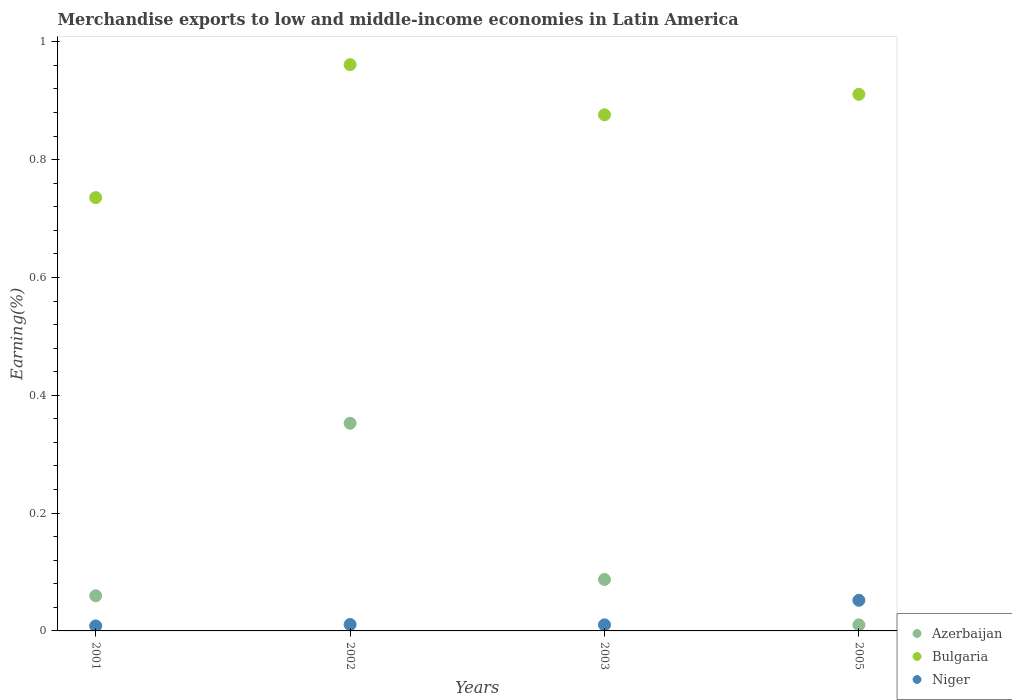What is the percentage of amount earned from merchandise exports in Bulgaria in 2002?
Give a very brief answer. 0.96. Across all years, what is the maximum percentage of amount earned from merchandise exports in Bulgaria?
Ensure brevity in your answer.  0.96. Across all years, what is the minimum percentage of amount earned from merchandise exports in Azerbaijan?
Your response must be concise. 0.01. In which year was the percentage of amount earned from merchandise exports in Niger maximum?
Provide a succinct answer. 2005. What is the total percentage of amount earned from merchandise exports in Azerbaijan in the graph?
Offer a terse response. 0.51. What is the difference between the percentage of amount earned from merchandise exports in Niger in 2001 and that in 2005?
Keep it short and to the point. -0.04. What is the difference between the percentage of amount earned from merchandise exports in Niger in 2003 and the percentage of amount earned from merchandise exports in Azerbaijan in 2005?
Offer a terse response. 3.905054811760046e-5. What is the average percentage of amount earned from merchandise exports in Azerbaijan per year?
Your answer should be very brief. 0.13. In the year 2003, what is the difference between the percentage of amount earned from merchandise exports in Bulgaria and percentage of amount earned from merchandise exports in Azerbaijan?
Make the answer very short. 0.79. What is the ratio of the percentage of amount earned from merchandise exports in Niger in 2002 to that in 2005?
Offer a very short reply. 0.21. Is the difference between the percentage of amount earned from merchandise exports in Bulgaria in 2002 and 2005 greater than the difference between the percentage of amount earned from merchandise exports in Azerbaijan in 2002 and 2005?
Make the answer very short. No. What is the difference between the highest and the second highest percentage of amount earned from merchandise exports in Bulgaria?
Provide a short and direct response. 0.05. What is the difference between the highest and the lowest percentage of amount earned from merchandise exports in Niger?
Make the answer very short. 0.04. Is the sum of the percentage of amount earned from merchandise exports in Bulgaria in 2001 and 2003 greater than the maximum percentage of amount earned from merchandise exports in Niger across all years?
Your response must be concise. Yes. Is it the case that in every year, the sum of the percentage of amount earned from merchandise exports in Niger and percentage of amount earned from merchandise exports in Bulgaria  is greater than the percentage of amount earned from merchandise exports in Azerbaijan?
Make the answer very short. Yes. Does the percentage of amount earned from merchandise exports in Azerbaijan monotonically increase over the years?
Your answer should be compact. No. How many dotlines are there?
Your answer should be very brief. 3. How many years are there in the graph?
Offer a very short reply. 4. What is the difference between two consecutive major ticks on the Y-axis?
Keep it short and to the point. 0.2. Does the graph contain any zero values?
Provide a short and direct response. No. Does the graph contain grids?
Make the answer very short. No. How are the legend labels stacked?
Make the answer very short. Vertical. What is the title of the graph?
Offer a very short reply. Merchandise exports to low and middle-income economies in Latin America. Does "Tunisia" appear as one of the legend labels in the graph?
Make the answer very short. No. What is the label or title of the X-axis?
Keep it short and to the point. Years. What is the label or title of the Y-axis?
Offer a very short reply. Earning(%). What is the Earning(%) in Azerbaijan in 2001?
Ensure brevity in your answer.  0.06. What is the Earning(%) in Bulgaria in 2001?
Keep it short and to the point. 0.74. What is the Earning(%) in Niger in 2001?
Make the answer very short. 0.01. What is the Earning(%) in Azerbaijan in 2002?
Ensure brevity in your answer.  0.35. What is the Earning(%) of Bulgaria in 2002?
Offer a terse response. 0.96. What is the Earning(%) of Niger in 2002?
Your response must be concise. 0.01. What is the Earning(%) of Azerbaijan in 2003?
Make the answer very short. 0.09. What is the Earning(%) in Bulgaria in 2003?
Ensure brevity in your answer.  0.88. What is the Earning(%) of Niger in 2003?
Your answer should be very brief. 0.01. What is the Earning(%) of Azerbaijan in 2005?
Offer a terse response. 0.01. What is the Earning(%) in Bulgaria in 2005?
Ensure brevity in your answer.  0.91. What is the Earning(%) in Niger in 2005?
Your response must be concise. 0.05. Across all years, what is the maximum Earning(%) in Azerbaijan?
Your answer should be very brief. 0.35. Across all years, what is the maximum Earning(%) in Bulgaria?
Make the answer very short. 0.96. Across all years, what is the maximum Earning(%) of Niger?
Offer a terse response. 0.05. Across all years, what is the minimum Earning(%) of Azerbaijan?
Your answer should be very brief. 0.01. Across all years, what is the minimum Earning(%) in Bulgaria?
Your answer should be compact. 0.74. Across all years, what is the minimum Earning(%) of Niger?
Provide a short and direct response. 0.01. What is the total Earning(%) of Azerbaijan in the graph?
Offer a very short reply. 0.51. What is the total Earning(%) in Bulgaria in the graph?
Ensure brevity in your answer.  3.48. What is the total Earning(%) of Niger in the graph?
Your response must be concise. 0.08. What is the difference between the Earning(%) in Azerbaijan in 2001 and that in 2002?
Give a very brief answer. -0.29. What is the difference between the Earning(%) of Bulgaria in 2001 and that in 2002?
Offer a terse response. -0.23. What is the difference between the Earning(%) in Niger in 2001 and that in 2002?
Provide a short and direct response. -0. What is the difference between the Earning(%) in Azerbaijan in 2001 and that in 2003?
Your answer should be compact. -0.03. What is the difference between the Earning(%) in Bulgaria in 2001 and that in 2003?
Keep it short and to the point. -0.14. What is the difference between the Earning(%) in Niger in 2001 and that in 2003?
Your response must be concise. -0. What is the difference between the Earning(%) of Azerbaijan in 2001 and that in 2005?
Provide a succinct answer. 0.05. What is the difference between the Earning(%) of Bulgaria in 2001 and that in 2005?
Your answer should be compact. -0.18. What is the difference between the Earning(%) of Niger in 2001 and that in 2005?
Your response must be concise. -0.04. What is the difference between the Earning(%) of Azerbaijan in 2002 and that in 2003?
Your answer should be very brief. 0.27. What is the difference between the Earning(%) in Bulgaria in 2002 and that in 2003?
Offer a very short reply. 0.09. What is the difference between the Earning(%) in Azerbaijan in 2002 and that in 2005?
Offer a terse response. 0.34. What is the difference between the Earning(%) of Bulgaria in 2002 and that in 2005?
Provide a short and direct response. 0.05. What is the difference between the Earning(%) in Niger in 2002 and that in 2005?
Keep it short and to the point. -0.04. What is the difference between the Earning(%) of Azerbaijan in 2003 and that in 2005?
Your answer should be compact. 0.08. What is the difference between the Earning(%) in Bulgaria in 2003 and that in 2005?
Keep it short and to the point. -0.03. What is the difference between the Earning(%) in Niger in 2003 and that in 2005?
Ensure brevity in your answer.  -0.04. What is the difference between the Earning(%) of Azerbaijan in 2001 and the Earning(%) of Bulgaria in 2002?
Your answer should be compact. -0.9. What is the difference between the Earning(%) in Azerbaijan in 2001 and the Earning(%) in Niger in 2002?
Your answer should be compact. 0.05. What is the difference between the Earning(%) of Bulgaria in 2001 and the Earning(%) of Niger in 2002?
Give a very brief answer. 0.72. What is the difference between the Earning(%) in Azerbaijan in 2001 and the Earning(%) in Bulgaria in 2003?
Make the answer very short. -0.82. What is the difference between the Earning(%) of Azerbaijan in 2001 and the Earning(%) of Niger in 2003?
Your answer should be very brief. 0.05. What is the difference between the Earning(%) of Bulgaria in 2001 and the Earning(%) of Niger in 2003?
Your answer should be very brief. 0.73. What is the difference between the Earning(%) in Azerbaijan in 2001 and the Earning(%) in Bulgaria in 2005?
Ensure brevity in your answer.  -0.85. What is the difference between the Earning(%) of Azerbaijan in 2001 and the Earning(%) of Niger in 2005?
Ensure brevity in your answer.  0.01. What is the difference between the Earning(%) of Bulgaria in 2001 and the Earning(%) of Niger in 2005?
Your answer should be compact. 0.68. What is the difference between the Earning(%) in Azerbaijan in 2002 and the Earning(%) in Bulgaria in 2003?
Give a very brief answer. -0.52. What is the difference between the Earning(%) of Azerbaijan in 2002 and the Earning(%) of Niger in 2003?
Give a very brief answer. 0.34. What is the difference between the Earning(%) in Bulgaria in 2002 and the Earning(%) in Niger in 2003?
Your answer should be compact. 0.95. What is the difference between the Earning(%) of Azerbaijan in 2002 and the Earning(%) of Bulgaria in 2005?
Your response must be concise. -0.56. What is the difference between the Earning(%) of Azerbaijan in 2002 and the Earning(%) of Niger in 2005?
Provide a succinct answer. 0.3. What is the difference between the Earning(%) of Bulgaria in 2002 and the Earning(%) of Niger in 2005?
Keep it short and to the point. 0.91. What is the difference between the Earning(%) in Azerbaijan in 2003 and the Earning(%) in Bulgaria in 2005?
Your response must be concise. -0.82. What is the difference between the Earning(%) in Azerbaijan in 2003 and the Earning(%) in Niger in 2005?
Your answer should be very brief. 0.04. What is the difference between the Earning(%) in Bulgaria in 2003 and the Earning(%) in Niger in 2005?
Offer a very short reply. 0.82. What is the average Earning(%) of Azerbaijan per year?
Provide a short and direct response. 0.13. What is the average Earning(%) of Bulgaria per year?
Make the answer very short. 0.87. What is the average Earning(%) in Niger per year?
Ensure brevity in your answer.  0.02. In the year 2001, what is the difference between the Earning(%) in Azerbaijan and Earning(%) in Bulgaria?
Your answer should be very brief. -0.68. In the year 2001, what is the difference between the Earning(%) in Azerbaijan and Earning(%) in Niger?
Make the answer very short. 0.05. In the year 2001, what is the difference between the Earning(%) of Bulgaria and Earning(%) of Niger?
Give a very brief answer. 0.73. In the year 2002, what is the difference between the Earning(%) of Azerbaijan and Earning(%) of Bulgaria?
Offer a very short reply. -0.61. In the year 2002, what is the difference between the Earning(%) in Azerbaijan and Earning(%) in Niger?
Your answer should be compact. 0.34. In the year 2002, what is the difference between the Earning(%) of Bulgaria and Earning(%) of Niger?
Keep it short and to the point. 0.95. In the year 2003, what is the difference between the Earning(%) in Azerbaijan and Earning(%) in Bulgaria?
Your response must be concise. -0.79. In the year 2003, what is the difference between the Earning(%) in Azerbaijan and Earning(%) in Niger?
Provide a short and direct response. 0.08. In the year 2003, what is the difference between the Earning(%) in Bulgaria and Earning(%) in Niger?
Your answer should be very brief. 0.87. In the year 2005, what is the difference between the Earning(%) in Azerbaijan and Earning(%) in Bulgaria?
Your answer should be very brief. -0.9. In the year 2005, what is the difference between the Earning(%) of Azerbaijan and Earning(%) of Niger?
Offer a very short reply. -0.04. In the year 2005, what is the difference between the Earning(%) of Bulgaria and Earning(%) of Niger?
Provide a succinct answer. 0.86. What is the ratio of the Earning(%) of Azerbaijan in 2001 to that in 2002?
Give a very brief answer. 0.17. What is the ratio of the Earning(%) of Bulgaria in 2001 to that in 2002?
Provide a short and direct response. 0.77. What is the ratio of the Earning(%) of Niger in 2001 to that in 2002?
Provide a short and direct response. 0.78. What is the ratio of the Earning(%) in Azerbaijan in 2001 to that in 2003?
Your answer should be compact. 0.68. What is the ratio of the Earning(%) in Bulgaria in 2001 to that in 2003?
Keep it short and to the point. 0.84. What is the ratio of the Earning(%) of Niger in 2001 to that in 2003?
Provide a short and direct response. 0.82. What is the ratio of the Earning(%) of Azerbaijan in 2001 to that in 2005?
Give a very brief answer. 5.8. What is the ratio of the Earning(%) in Bulgaria in 2001 to that in 2005?
Ensure brevity in your answer.  0.81. What is the ratio of the Earning(%) of Niger in 2001 to that in 2005?
Offer a very short reply. 0.16. What is the ratio of the Earning(%) in Azerbaijan in 2002 to that in 2003?
Your response must be concise. 4.04. What is the ratio of the Earning(%) of Bulgaria in 2002 to that in 2003?
Offer a very short reply. 1.1. What is the ratio of the Earning(%) in Niger in 2002 to that in 2003?
Your answer should be very brief. 1.05. What is the ratio of the Earning(%) in Azerbaijan in 2002 to that in 2005?
Ensure brevity in your answer.  34.23. What is the ratio of the Earning(%) of Bulgaria in 2002 to that in 2005?
Keep it short and to the point. 1.06. What is the ratio of the Earning(%) of Niger in 2002 to that in 2005?
Offer a terse response. 0.21. What is the ratio of the Earning(%) of Azerbaijan in 2003 to that in 2005?
Your response must be concise. 8.48. What is the ratio of the Earning(%) of Bulgaria in 2003 to that in 2005?
Provide a succinct answer. 0.96. What is the ratio of the Earning(%) in Niger in 2003 to that in 2005?
Make the answer very short. 0.2. What is the difference between the highest and the second highest Earning(%) of Azerbaijan?
Your answer should be very brief. 0.27. What is the difference between the highest and the second highest Earning(%) in Bulgaria?
Offer a terse response. 0.05. What is the difference between the highest and the second highest Earning(%) of Niger?
Your answer should be compact. 0.04. What is the difference between the highest and the lowest Earning(%) in Azerbaijan?
Keep it short and to the point. 0.34. What is the difference between the highest and the lowest Earning(%) of Bulgaria?
Keep it short and to the point. 0.23. What is the difference between the highest and the lowest Earning(%) of Niger?
Provide a short and direct response. 0.04. 